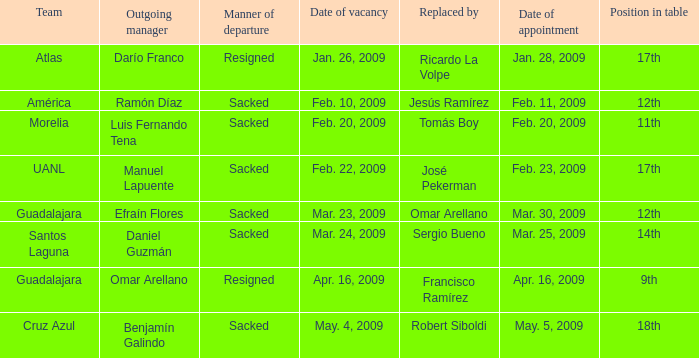What is Position in Table, when Replaced By is "Sergio Bueno"? 14th. 